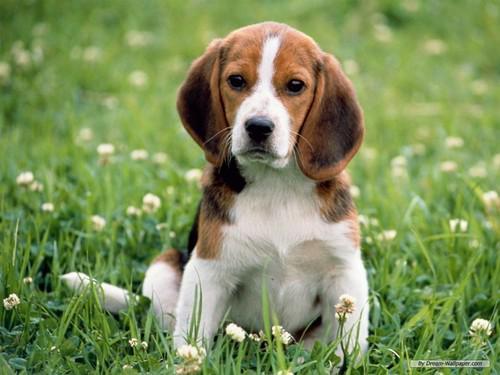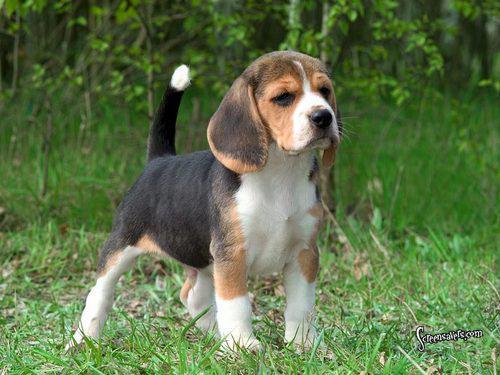The first image is the image on the left, the second image is the image on the right. Evaluate the accuracy of this statement regarding the images: "The puppy in the right image is bounding across the grass.". Is it true? Answer yes or no. No. 